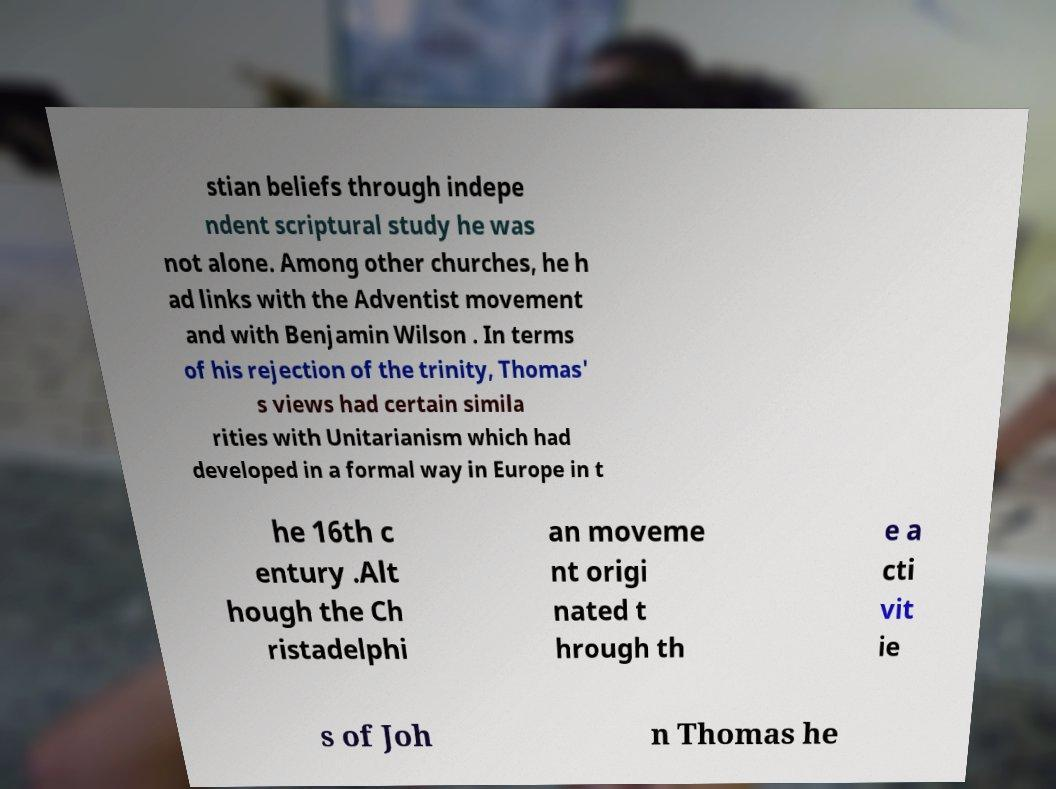For documentation purposes, I need the text within this image transcribed. Could you provide that? stian beliefs through indepe ndent scriptural study he was not alone. Among other churches, he h ad links with the Adventist movement and with Benjamin Wilson . In terms of his rejection of the trinity, Thomas' s views had certain simila rities with Unitarianism which had developed in a formal way in Europe in t he 16th c entury .Alt hough the Ch ristadelphi an moveme nt origi nated t hrough th e a cti vit ie s of Joh n Thomas he 